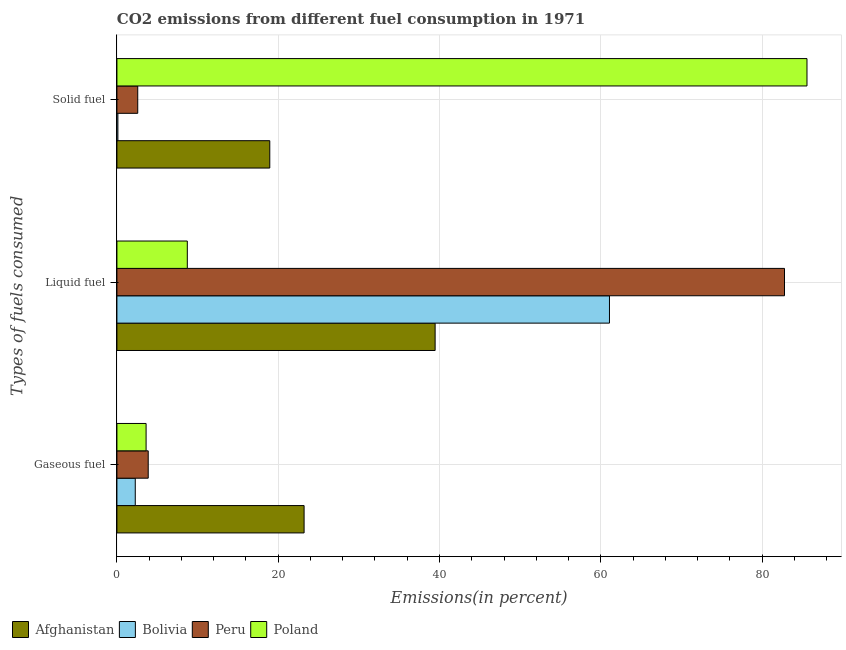How many different coloured bars are there?
Your response must be concise. 4. How many groups of bars are there?
Provide a short and direct response. 3. Are the number of bars per tick equal to the number of legend labels?
Your answer should be compact. Yes. How many bars are there on the 3rd tick from the top?
Offer a very short reply. 4. What is the label of the 3rd group of bars from the top?
Offer a terse response. Gaseous fuel. What is the percentage of solid fuel emission in Poland?
Your answer should be very brief. 85.57. Across all countries, what is the maximum percentage of solid fuel emission?
Provide a short and direct response. 85.57. Across all countries, what is the minimum percentage of gaseous fuel emission?
Give a very brief answer. 2.28. What is the total percentage of liquid fuel emission in the graph?
Give a very brief answer. 192.05. What is the difference between the percentage of solid fuel emission in Peru and that in Poland?
Provide a short and direct response. -82.99. What is the difference between the percentage of gaseous fuel emission in Afghanistan and the percentage of liquid fuel emission in Peru?
Offer a terse response. -59.57. What is the average percentage of gaseous fuel emission per country?
Make the answer very short. 8.25. What is the difference between the percentage of solid fuel emission and percentage of liquid fuel emission in Afghanistan?
Make the answer very short. -20.5. What is the ratio of the percentage of solid fuel emission in Bolivia to that in Afghanistan?
Provide a short and direct response. 0.01. Is the difference between the percentage of gaseous fuel emission in Peru and Bolivia greater than the difference between the percentage of liquid fuel emission in Peru and Bolivia?
Offer a terse response. No. What is the difference between the highest and the second highest percentage of liquid fuel emission?
Your response must be concise. 21.7. What is the difference between the highest and the lowest percentage of solid fuel emission?
Your answer should be compact. 85.45. In how many countries, is the percentage of solid fuel emission greater than the average percentage of solid fuel emission taken over all countries?
Your response must be concise. 1. Is the sum of the percentage of solid fuel emission in Bolivia and Poland greater than the maximum percentage of gaseous fuel emission across all countries?
Keep it short and to the point. Yes. What does the 1st bar from the top in Solid fuel represents?
Make the answer very short. Poland. Is it the case that in every country, the sum of the percentage of gaseous fuel emission and percentage of liquid fuel emission is greater than the percentage of solid fuel emission?
Provide a succinct answer. No. Are all the bars in the graph horizontal?
Give a very brief answer. Yes. How many countries are there in the graph?
Offer a very short reply. 4. What is the difference between two consecutive major ticks on the X-axis?
Provide a short and direct response. 20. Are the values on the major ticks of X-axis written in scientific E-notation?
Provide a succinct answer. No. Does the graph contain any zero values?
Ensure brevity in your answer.  No. What is the title of the graph?
Make the answer very short. CO2 emissions from different fuel consumption in 1971. Does "Upper middle income" appear as one of the legend labels in the graph?
Keep it short and to the point. No. What is the label or title of the X-axis?
Your response must be concise. Emissions(in percent). What is the label or title of the Y-axis?
Offer a very short reply. Types of fuels consumed. What is the Emissions(in percent) in Afghanistan in Gaseous fuel?
Your response must be concise. 23.21. What is the Emissions(in percent) in Bolivia in Gaseous fuel?
Your response must be concise. 2.28. What is the Emissions(in percent) in Peru in Gaseous fuel?
Keep it short and to the point. 3.88. What is the Emissions(in percent) of Poland in Gaseous fuel?
Provide a succinct answer. 3.62. What is the Emissions(in percent) in Afghanistan in Liquid fuel?
Ensure brevity in your answer.  39.46. What is the Emissions(in percent) in Bolivia in Liquid fuel?
Your response must be concise. 61.08. What is the Emissions(in percent) in Peru in Liquid fuel?
Provide a succinct answer. 82.78. What is the Emissions(in percent) of Poland in Liquid fuel?
Make the answer very short. 8.73. What is the Emissions(in percent) in Afghanistan in Solid fuel?
Keep it short and to the point. 18.96. What is the Emissions(in percent) of Bolivia in Solid fuel?
Make the answer very short. 0.12. What is the Emissions(in percent) of Peru in Solid fuel?
Your response must be concise. 2.58. What is the Emissions(in percent) of Poland in Solid fuel?
Your answer should be compact. 85.57. Across all Types of fuels consumed, what is the maximum Emissions(in percent) of Afghanistan?
Your response must be concise. 39.46. Across all Types of fuels consumed, what is the maximum Emissions(in percent) in Bolivia?
Your response must be concise. 61.08. Across all Types of fuels consumed, what is the maximum Emissions(in percent) in Peru?
Offer a very short reply. 82.78. Across all Types of fuels consumed, what is the maximum Emissions(in percent) in Poland?
Your response must be concise. 85.57. Across all Types of fuels consumed, what is the minimum Emissions(in percent) of Afghanistan?
Keep it short and to the point. 18.96. Across all Types of fuels consumed, what is the minimum Emissions(in percent) in Bolivia?
Your response must be concise. 0.12. Across all Types of fuels consumed, what is the minimum Emissions(in percent) in Peru?
Offer a very short reply. 2.58. Across all Types of fuels consumed, what is the minimum Emissions(in percent) of Poland?
Provide a succinct answer. 3.62. What is the total Emissions(in percent) in Afghanistan in the graph?
Your answer should be compact. 81.62. What is the total Emissions(in percent) of Bolivia in the graph?
Offer a very short reply. 63.47. What is the total Emissions(in percent) of Peru in the graph?
Your answer should be compact. 89.24. What is the total Emissions(in percent) in Poland in the graph?
Provide a short and direct response. 97.92. What is the difference between the Emissions(in percent) in Afghanistan in Gaseous fuel and that in Liquid fuel?
Offer a terse response. -16.25. What is the difference between the Emissions(in percent) in Bolivia in Gaseous fuel and that in Liquid fuel?
Your answer should be very brief. -58.8. What is the difference between the Emissions(in percent) in Peru in Gaseous fuel and that in Liquid fuel?
Offer a terse response. -78.9. What is the difference between the Emissions(in percent) of Poland in Gaseous fuel and that in Liquid fuel?
Your answer should be very brief. -5.11. What is the difference between the Emissions(in percent) of Afghanistan in Gaseous fuel and that in Solid fuel?
Provide a short and direct response. 4.26. What is the difference between the Emissions(in percent) of Bolivia in Gaseous fuel and that in Solid fuel?
Give a very brief answer. 2.16. What is the difference between the Emissions(in percent) of Peru in Gaseous fuel and that in Solid fuel?
Offer a very short reply. 1.3. What is the difference between the Emissions(in percent) in Poland in Gaseous fuel and that in Solid fuel?
Your response must be concise. -81.95. What is the difference between the Emissions(in percent) in Afghanistan in Liquid fuel and that in Solid fuel?
Offer a terse response. 20.5. What is the difference between the Emissions(in percent) of Bolivia in Liquid fuel and that in Solid fuel?
Offer a very short reply. 60.96. What is the difference between the Emissions(in percent) in Peru in Liquid fuel and that in Solid fuel?
Your response must be concise. 80.2. What is the difference between the Emissions(in percent) of Poland in Liquid fuel and that in Solid fuel?
Your answer should be compact. -76.84. What is the difference between the Emissions(in percent) of Afghanistan in Gaseous fuel and the Emissions(in percent) of Bolivia in Liquid fuel?
Keep it short and to the point. -37.87. What is the difference between the Emissions(in percent) in Afghanistan in Gaseous fuel and the Emissions(in percent) in Peru in Liquid fuel?
Give a very brief answer. -59.57. What is the difference between the Emissions(in percent) in Afghanistan in Gaseous fuel and the Emissions(in percent) in Poland in Liquid fuel?
Offer a terse response. 14.48. What is the difference between the Emissions(in percent) of Bolivia in Gaseous fuel and the Emissions(in percent) of Peru in Liquid fuel?
Ensure brevity in your answer.  -80.51. What is the difference between the Emissions(in percent) in Bolivia in Gaseous fuel and the Emissions(in percent) in Poland in Liquid fuel?
Make the answer very short. -6.45. What is the difference between the Emissions(in percent) in Peru in Gaseous fuel and the Emissions(in percent) in Poland in Liquid fuel?
Your answer should be very brief. -4.85. What is the difference between the Emissions(in percent) in Afghanistan in Gaseous fuel and the Emissions(in percent) in Bolivia in Solid fuel?
Provide a succinct answer. 23.09. What is the difference between the Emissions(in percent) of Afghanistan in Gaseous fuel and the Emissions(in percent) of Peru in Solid fuel?
Ensure brevity in your answer.  20.63. What is the difference between the Emissions(in percent) of Afghanistan in Gaseous fuel and the Emissions(in percent) of Poland in Solid fuel?
Keep it short and to the point. -62.36. What is the difference between the Emissions(in percent) of Bolivia in Gaseous fuel and the Emissions(in percent) of Peru in Solid fuel?
Offer a very short reply. -0.31. What is the difference between the Emissions(in percent) of Bolivia in Gaseous fuel and the Emissions(in percent) of Poland in Solid fuel?
Keep it short and to the point. -83.3. What is the difference between the Emissions(in percent) in Peru in Gaseous fuel and the Emissions(in percent) in Poland in Solid fuel?
Your response must be concise. -81.69. What is the difference between the Emissions(in percent) in Afghanistan in Liquid fuel and the Emissions(in percent) in Bolivia in Solid fuel?
Your response must be concise. 39.34. What is the difference between the Emissions(in percent) in Afghanistan in Liquid fuel and the Emissions(in percent) in Peru in Solid fuel?
Make the answer very short. 36.88. What is the difference between the Emissions(in percent) of Afghanistan in Liquid fuel and the Emissions(in percent) of Poland in Solid fuel?
Keep it short and to the point. -46.11. What is the difference between the Emissions(in percent) of Bolivia in Liquid fuel and the Emissions(in percent) of Peru in Solid fuel?
Keep it short and to the point. 58.5. What is the difference between the Emissions(in percent) of Bolivia in Liquid fuel and the Emissions(in percent) of Poland in Solid fuel?
Your answer should be very brief. -24.49. What is the difference between the Emissions(in percent) in Peru in Liquid fuel and the Emissions(in percent) in Poland in Solid fuel?
Keep it short and to the point. -2.79. What is the average Emissions(in percent) in Afghanistan per Types of fuels consumed?
Provide a succinct answer. 27.21. What is the average Emissions(in percent) of Bolivia per Types of fuels consumed?
Provide a short and direct response. 21.16. What is the average Emissions(in percent) of Peru per Types of fuels consumed?
Give a very brief answer. 29.75. What is the average Emissions(in percent) in Poland per Types of fuels consumed?
Your answer should be compact. 32.64. What is the difference between the Emissions(in percent) in Afghanistan and Emissions(in percent) in Bolivia in Gaseous fuel?
Offer a terse response. 20.94. What is the difference between the Emissions(in percent) of Afghanistan and Emissions(in percent) of Peru in Gaseous fuel?
Your answer should be compact. 19.33. What is the difference between the Emissions(in percent) of Afghanistan and Emissions(in percent) of Poland in Gaseous fuel?
Give a very brief answer. 19.59. What is the difference between the Emissions(in percent) of Bolivia and Emissions(in percent) of Peru in Gaseous fuel?
Offer a very short reply. -1.61. What is the difference between the Emissions(in percent) of Bolivia and Emissions(in percent) of Poland in Gaseous fuel?
Provide a short and direct response. -1.34. What is the difference between the Emissions(in percent) of Peru and Emissions(in percent) of Poland in Gaseous fuel?
Ensure brevity in your answer.  0.26. What is the difference between the Emissions(in percent) in Afghanistan and Emissions(in percent) in Bolivia in Liquid fuel?
Your response must be concise. -21.62. What is the difference between the Emissions(in percent) in Afghanistan and Emissions(in percent) in Peru in Liquid fuel?
Provide a succinct answer. -43.32. What is the difference between the Emissions(in percent) of Afghanistan and Emissions(in percent) of Poland in Liquid fuel?
Make the answer very short. 30.73. What is the difference between the Emissions(in percent) of Bolivia and Emissions(in percent) of Peru in Liquid fuel?
Your answer should be compact. -21.7. What is the difference between the Emissions(in percent) in Bolivia and Emissions(in percent) in Poland in Liquid fuel?
Your answer should be very brief. 52.35. What is the difference between the Emissions(in percent) of Peru and Emissions(in percent) of Poland in Liquid fuel?
Your answer should be compact. 74.05. What is the difference between the Emissions(in percent) in Afghanistan and Emissions(in percent) in Bolivia in Solid fuel?
Make the answer very short. 18.84. What is the difference between the Emissions(in percent) of Afghanistan and Emissions(in percent) of Peru in Solid fuel?
Provide a succinct answer. 16.37. What is the difference between the Emissions(in percent) of Afghanistan and Emissions(in percent) of Poland in Solid fuel?
Offer a terse response. -66.62. What is the difference between the Emissions(in percent) of Bolivia and Emissions(in percent) of Peru in Solid fuel?
Keep it short and to the point. -2.46. What is the difference between the Emissions(in percent) in Bolivia and Emissions(in percent) in Poland in Solid fuel?
Provide a short and direct response. -85.45. What is the difference between the Emissions(in percent) of Peru and Emissions(in percent) of Poland in Solid fuel?
Your response must be concise. -82.99. What is the ratio of the Emissions(in percent) in Afghanistan in Gaseous fuel to that in Liquid fuel?
Provide a short and direct response. 0.59. What is the ratio of the Emissions(in percent) of Bolivia in Gaseous fuel to that in Liquid fuel?
Provide a succinct answer. 0.04. What is the ratio of the Emissions(in percent) in Peru in Gaseous fuel to that in Liquid fuel?
Ensure brevity in your answer.  0.05. What is the ratio of the Emissions(in percent) in Poland in Gaseous fuel to that in Liquid fuel?
Ensure brevity in your answer.  0.41. What is the ratio of the Emissions(in percent) in Afghanistan in Gaseous fuel to that in Solid fuel?
Keep it short and to the point. 1.22. What is the ratio of the Emissions(in percent) in Bolivia in Gaseous fuel to that in Solid fuel?
Give a very brief answer. 19. What is the ratio of the Emissions(in percent) of Peru in Gaseous fuel to that in Solid fuel?
Provide a succinct answer. 1.5. What is the ratio of the Emissions(in percent) in Poland in Gaseous fuel to that in Solid fuel?
Your answer should be very brief. 0.04. What is the ratio of the Emissions(in percent) of Afghanistan in Liquid fuel to that in Solid fuel?
Offer a terse response. 2.08. What is the ratio of the Emissions(in percent) in Bolivia in Liquid fuel to that in Solid fuel?
Your answer should be very brief. 510. What is the ratio of the Emissions(in percent) of Peru in Liquid fuel to that in Solid fuel?
Your answer should be compact. 32.08. What is the ratio of the Emissions(in percent) in Poland in Liquid fuel to that in Solid fuel?
Give a very brief answer. 0.1. What is the difference between the highest and the second highest Emissions(in percent) of Afghanistan?
Your response must be concise. 16.25. What is the difference between the highest and the second highest Emissions(in percent) in Bolivia?
Ensure brevity in your answer.  58.8. What is the difference between the highest and the second highest Emissions(in percent) of Peru?
Give a very brief answer. 78.9. What is the difference between the highest and the second highest Emissions(in percent) of Poland?
Offer a very short reply. 76.84. What is the difference between the highest and the lowest Emissions(in percent) in Afghanistan?
Give a very brief answer. 20.5. What is the difference between the highest and the lowest Emissions(in percent) in Bolivia?
Ensure brevity in your answer.  60.96. What is the difference between the highest and the lowest Emissions(in percent) of Peru?
Provide a short and direct response. 80.2. What is the difference between the highest and the lowest Emissions(in percent) in Poland?
Provide a short and direct response. 81.95. 